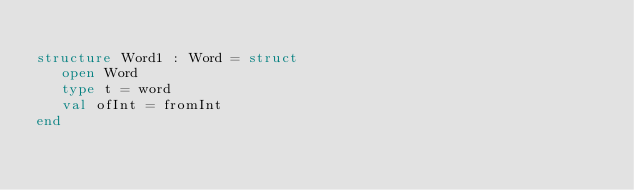<code> <loc_0><loc_0><loc_500><loc_500><_SML_>
structure Word1 : Word = struct
   open Word
   type t = word
   val ofInt = fromInt
end
</code> 